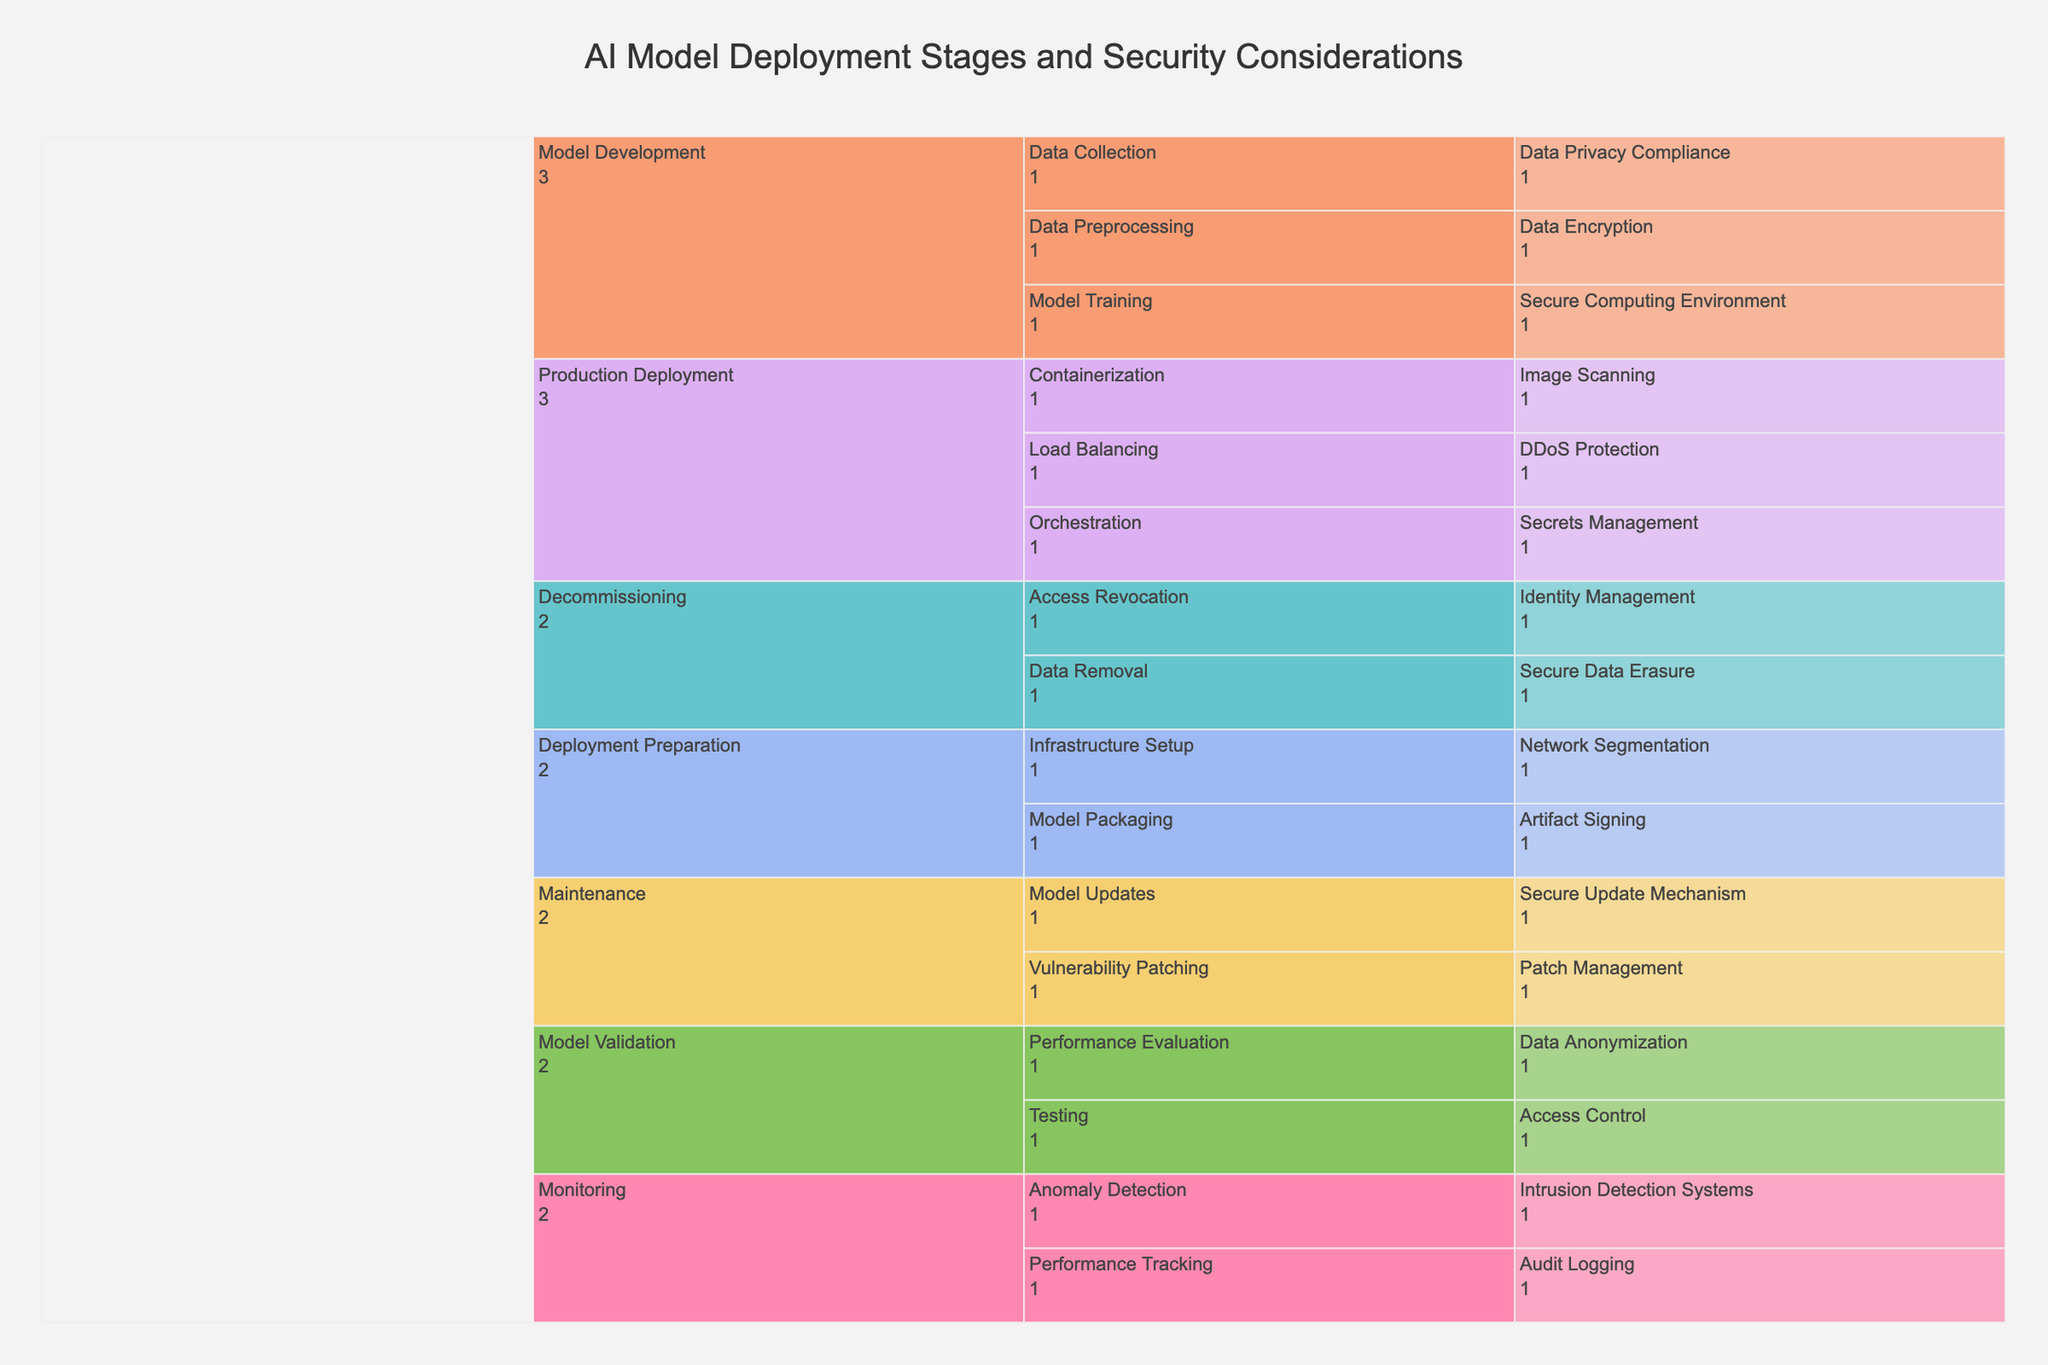What is the title of the Icicle Chart? The title is prominently displayed at the top of the chart. It is usually in a larger font and centered to grab the viewer's attention.
Answer: AI Model Deployment Stages and Security Considerations How many stages are listed in the Icicle Chart? To identify the number of stages in the Icicle Chart, count the first level categories under the root of the chart. These are the primary divisions directly under the main title.
Answer: 6 Which stage has 'Data Privacy Compliance' as a security consideration? Navigate through the stages and sub-stages of the chart until you find 'Data Privacy Compliance'. Trace back from 'Data Privacy Compliance' to its corresponding primary stage.
Answer: Model Development What security considerations are associated with the 'Deployment Preparation' stage? Locate the 'Deployment Preparation' stage and observe its sub-stages. List all the security considerations under these sub-stages.
Answer: Artifact Signing, Network Segmentation Which two sub-stages belong to the 'Anomaly Detection' security consideration? Find the 'Anomaly Detection' security consideration and trace back to determine its corresponding sub-stage and primary stage. This describes the hierarchy leading to 'Anomaly Detection'.
Answer: Monitoring Which has more sub-stages: 'Model Validation' or 'Monitoring'? Compare the number of sub-stages branching from both 'Model Validation' and 'Monitoring'. Count the branches directly under each stage to determine which has more sub-stages.
Answer: Model Validation In which stage does 'Patch Management' fall? Locate the 'Patch Management' security consideration in the chart. Then, trace back to identify both the sub-stage and the primary stage it falls under.
Answer: Maintenance What is the difference in the number of security considerations between 'Model Development' and 'Production Deployment'? Count the total security considerations under the 'Model Development' stage. Then, count the security considerations under the 'Production Deployment' stage. Subtract the smaller count from the larger to get the difference.
Answer: 1 Which stage includes 'Secure Data Erasure' and 'Access Revocation' as its security considerations? Locate both 'Secure Data Erasure' and 'Access Revocation' in the chart. Trace back both to their primary stage to determine the common stage they belong to.
Answer: Decommissioning 